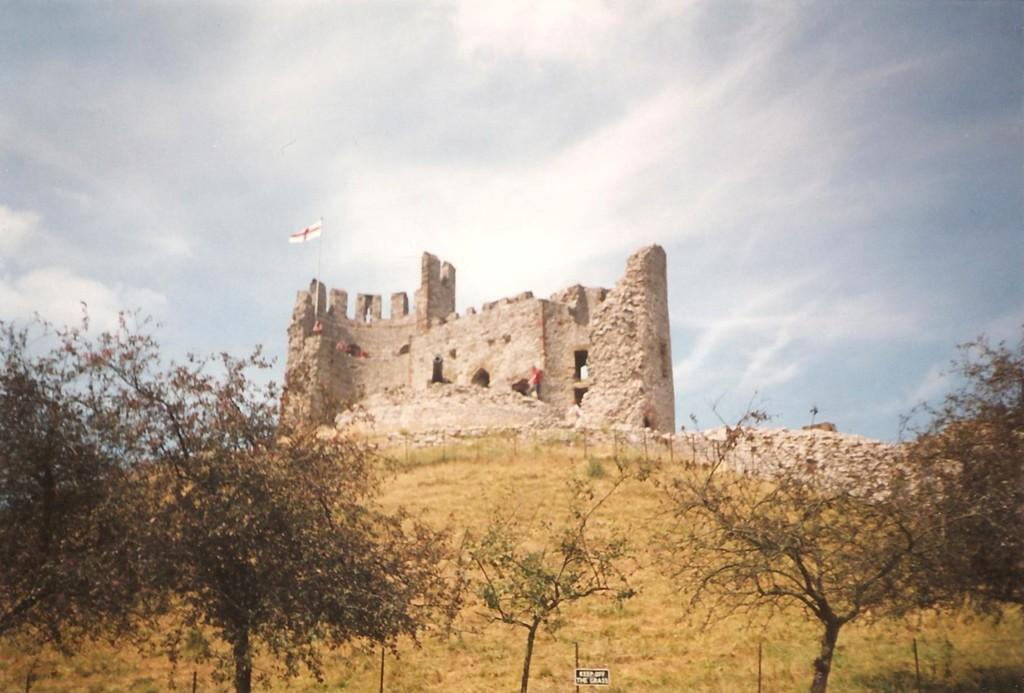What type of vegetation can be seen in the image? There are trees in the image. What structure is present in the image? There is a building in the image. What is attached to the building? There is a flag on the building. What can be seen in the background of the image? The sky is visible in the background of the image. What type of egg is used to make the jam in the image? There is no egg or jam present in the image. How is the division symbolized in the image? There is no division symbol or concept present in the image. 